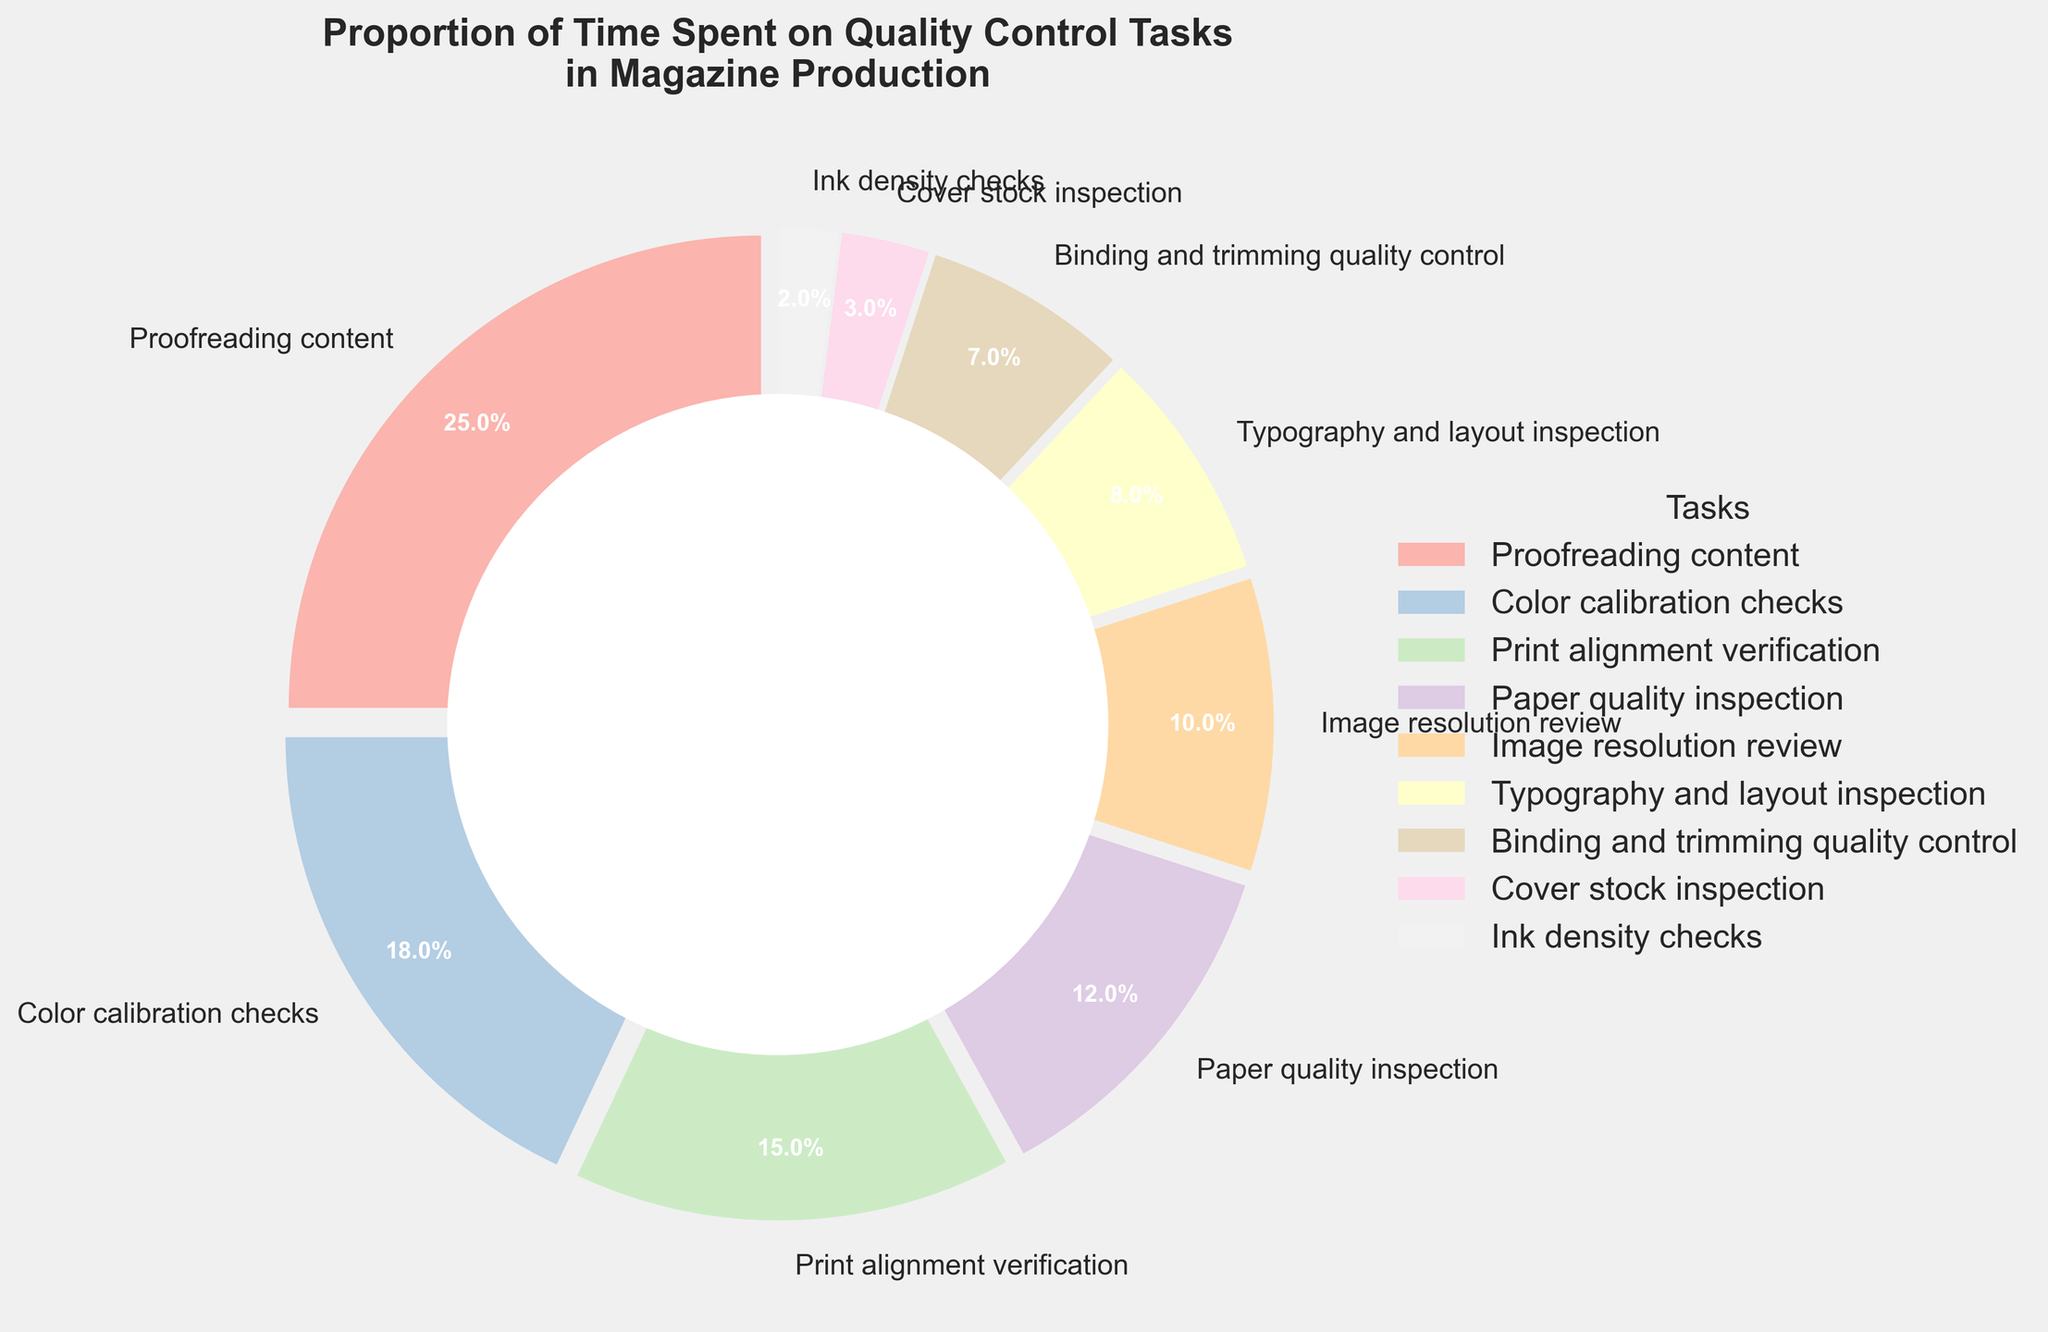What's the most time-consuming quality control task? According to the pie chart, the section designated for "Proofreading content" takes up the largest portion of the chart. Specifically, it represents 25% of the total time spent on quality control tasks.
Answer: Proofreading content Which task takes less time: "Ink density checks" or "Cover stock inspection"? The pie chart shows that "Ink density checks" takes up 2% of the time, which is smaller than "Cover stock inspection" that takes up 3%.
Answer: Ink density checks By how much percentage does "Color calibration checks" exceed "Image resolution review"? "Color calibration checks" accounts for 18% of the time, while "Image resolution review" accounts for 10%. The difference is calculated as 18% - 10% = 8%.
Answer: 8% What's the combined percentage of time spent on "Print alignment verification" and "Typography and layout inspection"? "Print alignment verification" takes up 15% and "Typography and layout inspection" takes up 8%. The combined total is 15% + 8% = 23%.
Answer: 23% Which task category has a noticeably smaller portion compared to "Paper quality inspection"? "Paper quality inspection" is 12% of the time spent, while "Binding and trimming quality control" is 7%, which is significantly smaller.
Answer: Binding and trimming quality control How does the proportion of time spent on "Binding and trimming quality control" compare to "Cover stock inspection"? "Binding and trimming quality control" is 7% of the time which is larger than "Cover stock inspection" which is 3%.
Answer: Binding and trimming quality control Is the percentage of time spent on "Print alignment verification" greater than the combined time spent on "Cover stock inspection" and "Ink density checks"? "Print alignment verification" takes 15% of the time. The combined time spent on "Cover stock inspection" (3%) and "Ink density checks" (2%) is 3% + 2% = 5%. Since 15% is greater than 5%, the answer is yes.
Answer: Yes Which section of the pie chart uses a visibly larger section, "Typography and layout inspection" or "Paper quality inspection"? "Paper quality inspection" uses 12% of the time while "Typography and layout inspection" uses 8%. The 12% section is larger than the 8% section.
Answer: Paper quality inspection 